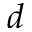<formula> <loc_0><loc_0><loc_500><loc_500>d</formula> 